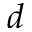<formula> <loc_0><loc_0><loc_500><loc_500>d</formula> 